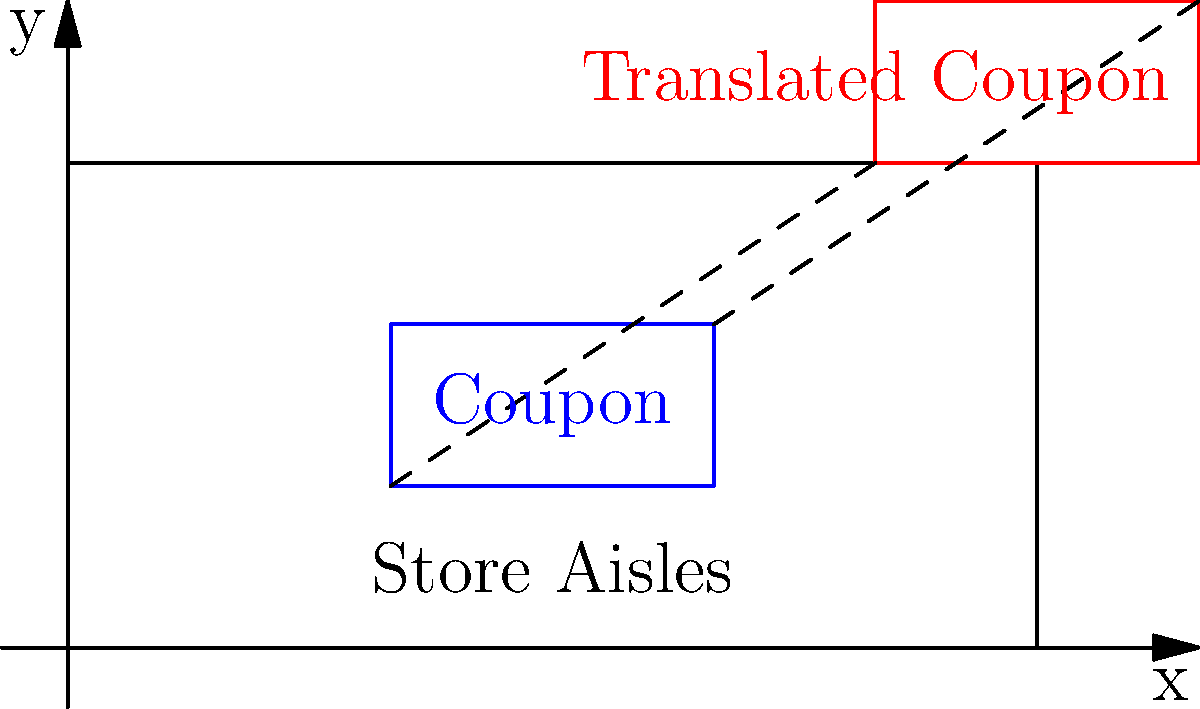A rectangular coupon with vertices at (2,1), (4,1), (4,2), and (2,2) is translated 3 units right and 2 units up across a coordinate plane representing store aisles. What are the coordinates of the translated coupon's top-right vertex? To solve this problem, we need to apply the concept of translation in transformational geometry. Here's a step-by-step explanation:

1. Identify the original coordinates of the top-right vertex of the coupon:
   The top-right vertex is at (4,2)

2. Determine the translation vector:
   The coupon is moved 3 units right (positive x-direction) and 2 units up (positive y-direction)
   Translation vector: (3,2)

3. Apply the translation to the top-right vertex:
   New x-coordinate = Original x-coordinate + x-translation
   $4 + 3 = 7$
   
   New y-coordinate = Original y-coordinate + y-translation
   $2 + 2 = 4$

4. Combine the new coordinates:
   The new top-right vertex is at (7,4)

Therefore, after translation, the coordinates of the coupon's top-right vertex are (7,4).
Answer: (7,4) 